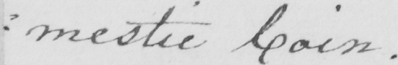What is written in this line of handwriting? : mestic Coin . 